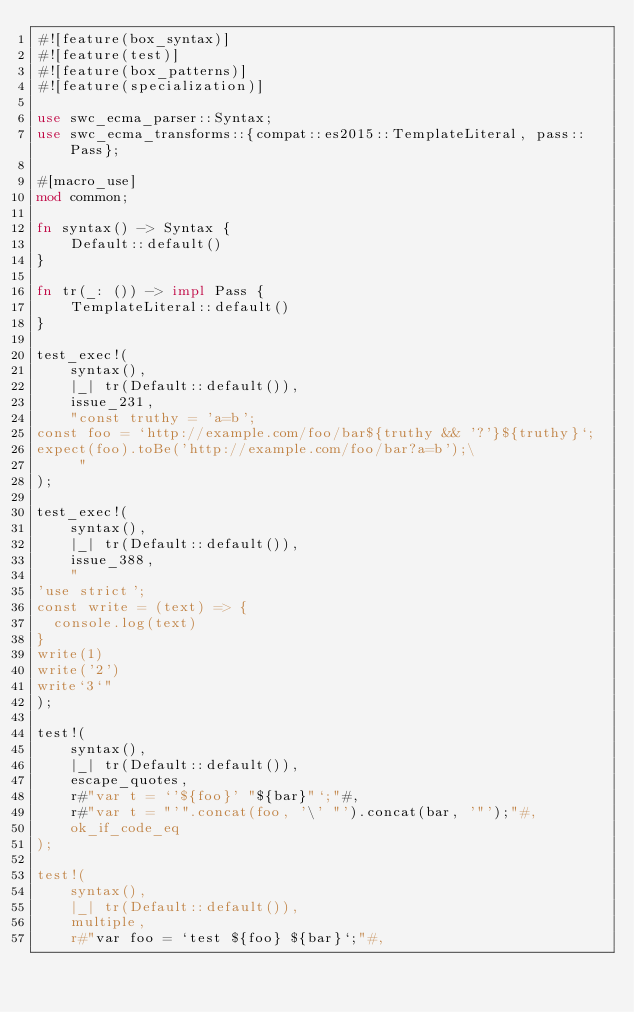Convert code to text. <code><loc_0><loc_0><loc_500><loc_500><_Rust_>#![feature(box_syntax)]
#![feature(test)]
#![feature(box_patterns)]
#![feature(specialization)]

use swc_ecma_parser::Syntax;
use swc_ecma_transforms::{compat::es2015::TemplateLiteral, pass::Pass};

#[macro_use]
mod common;

fn syntax() -> Syntax {
    Default::default()
}

fn tr(_: ()) -> impl Pass {
    TemplateLiteral::default()
}

test_exec!(
    syntax(),
    |_| tr(Default::default()),
    issue_231,
    "const truthy = 'a=b';
const foo = `http://example.com/foo/bar${truthy && '?'}${truthy}`;
expect(foo).toBe('http://example.com/foo/bar?a=b');\
     "
);

test_exec!(
    syntax(),
    |_| tr(Default::default()),
    issue_388,
    "
'use strict';
const write = (text) => {
  console.log(text)
}
write(1) 
write('2')
write`3`"
);

test!(
    syntax(),
    |_| tr(Default::default()),
    escape_quotes,
    r#"var t = `'${foo}' "${bar}"`;"#,
    r#"var t = "'".concat(foo, '\' "').concat(bar, '"');"#,
    ok_if_code_eq
);

test!(
    syntax(),
    |_| tr(Default::default()),
    multiple,
    r#"var foo = `test ${foo} ${bar}`;"#,</code> 